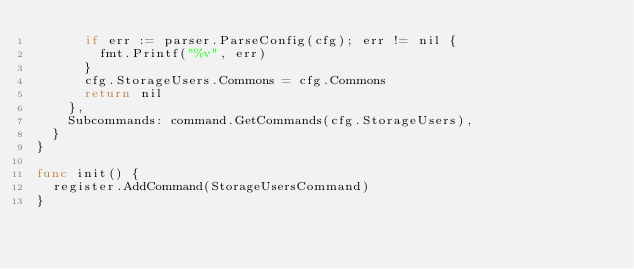<code> <loc_0><loc_0><loc_500><loc_500><_Go_>			if err := parser.ParseConfig(cfg); err != nil {
				fmt.Printf("%v", err)
			}
			cfg.StorageUsers.Commons = cfg.Commons
			return nil
		},
		Subcommands: command.GetCommands(cfg.StorageUsers),
	}
}

func init() {
	register.AddCommand(StorageUsersCommand)
}
</code> 